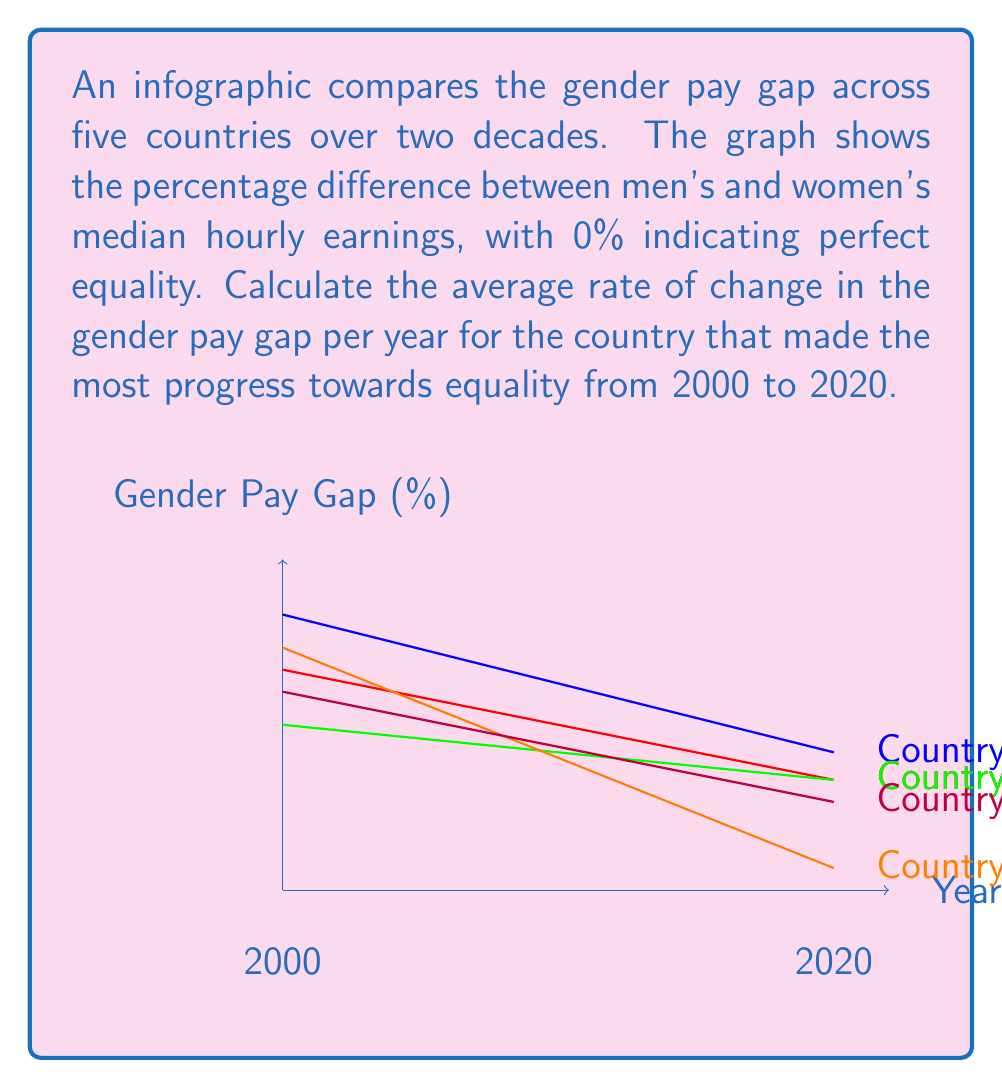What is the answer to this math problem? To solve this problem, we need to:

1. Identify the country that made the most progress towards equality.
2. Calculate the total change in the gender pay gap for that country.
3. Divide the total change by the number of years to get the average rate of change per year.

Step 1: Identifying the country with the most progress

We can determine this by looking at which line has the steepest downward slope. From the graph, Country D (orange line) appears to have the steepest slope.

Step 2: Calculating the total change

For Country D:
- In 2000 (x = 0), the gender pay gap was 22%
- In 2020 (x = 20), the gender pay gap was 2%

Total change = Initial value - Final value
$$\Delta y = 22\% - 2\% = 20\%$$

Step 3: Calculating the average rate of change per year

Average rate of change = Total change ÷ Number of years
$$\text{Rate} = \frac{\Delta y}{\Delta x} = \frac{20\%}{20 \text{ years}} = 1\% \text{ per year}$$

Therefore, the average rate of change in the gender pay gap for Country D is a decrease of 1% per year.
Answer: $-1\%$ per year 